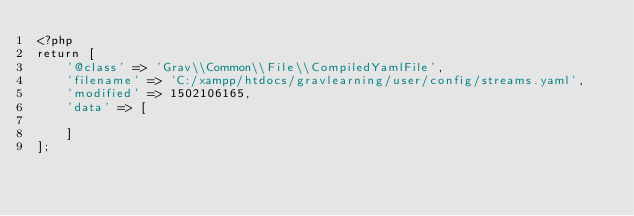<code> <loc_0><loc_0><loc_500><loc_500><_PHP_><?php
return [
    '@class' => 'Grav\\Common\\File\\CompiledYamlFile',
    'filename' => 'C:/xampp/htdocs/gravlearning/user/config/streams.yaml',
    'modified' => 1502106165,
    'data' => [
        
    ]
];
</code> 